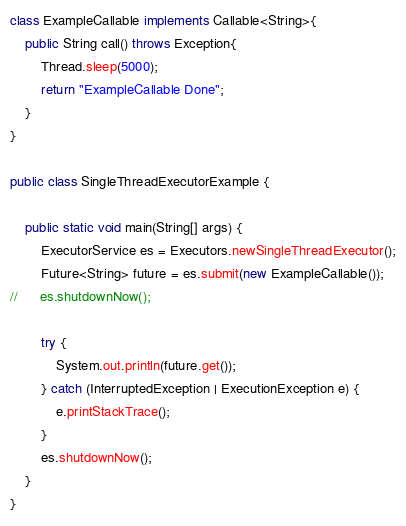<code> <loc_0><loc_0><loc_500><loc_500><_Java_>
class ExampleCallable implements Callable<String>{
	public String call() throws Exception{
		Thread.sleep(5000);
		return "ExampleCallable Done";
	}
}

public class SingleThreadExecutorExample {

	public static void main(String[] args) {
		ExecutorService es = Executors.newSingleThreadExecutor();
		Future<String> future = es.submit(new ExampleCallable());
//		es.shutdownNow();
		
		try {
			System.out.println(future.get());
		} catch (InterruptedException | ExecutionException e) {
			e.printStackTrace();
		}
		es.shutdownNow();
	}
}
</code> 